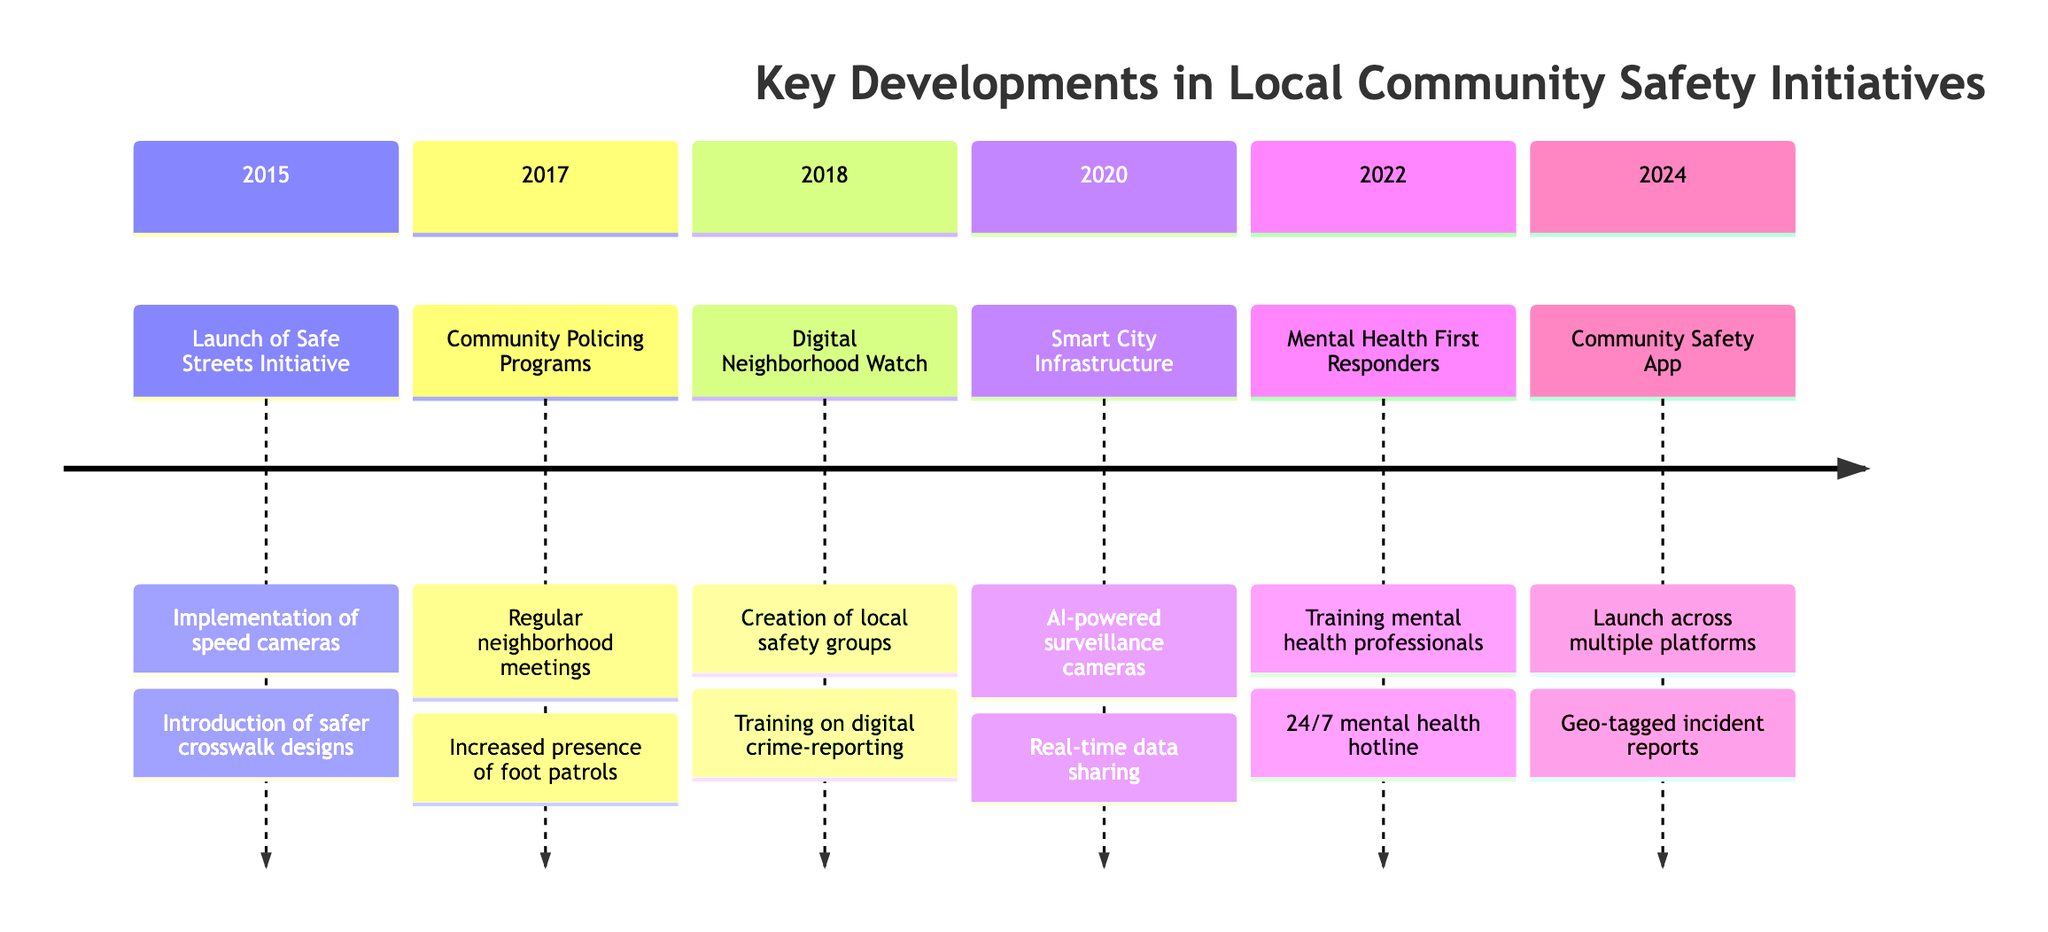What year did the Safe Streets Initiative launch? The Safe Streets Initiative is indicated to have launched in the year 2015 as the first entry on the timeline.
Answer: 2015 What program was established in 2017? The timeline specifies that in 2017, Community Policing Programs were established, detailing different initiatives aimed at building trust in neighborhoods.
Answer: Community Policing Programs How many key developments were listed for the year 2020? The timeline shows that there were two key developments listed for the year 2020, which are related to Smart City infrastructure.
Answer: 2 Which initiative introduced a 24/7 mental health emergency hotline? According to the timeline, the program associated with the mental health emergency hotline was expanded in 2022, under the Mental Health First Responders initiative.
Answer: Mental Health First Responders What was a notable feature of the Community Safety App launched in 2024? The 2024 entry mentions that one notable feature of the Community Safety App is geo-tagged incident reports, emphasizing its real-time capabilities.
Answer: Geo-tagged incident reports What type of technology was deployed in 2020 as part of the Smart City infrastructure? The timeline specifically mentions AI-powered surveillance cameras as a part of the technology deployed in 2020, highlighting the integration of advanced technology in community safety.
Answer: AI-powered surveillance cameras In which year was the Digital Neighborhood Watch program initiated? The timeline clearly marks the initiation year of the Digital Neighborhood Watch program as 2018, indicating its establishment within that period.
Answer: 2018 How did the Safe Streets Initiative aim to improve safety? The timeline states that the Safe Streets Initiative aimed to reduce traffic accidents and enhance pedestrian safety primarily through speed cameras and safer crosswalk designs.
Answer: Speed cameras and safer crosswalk designs 